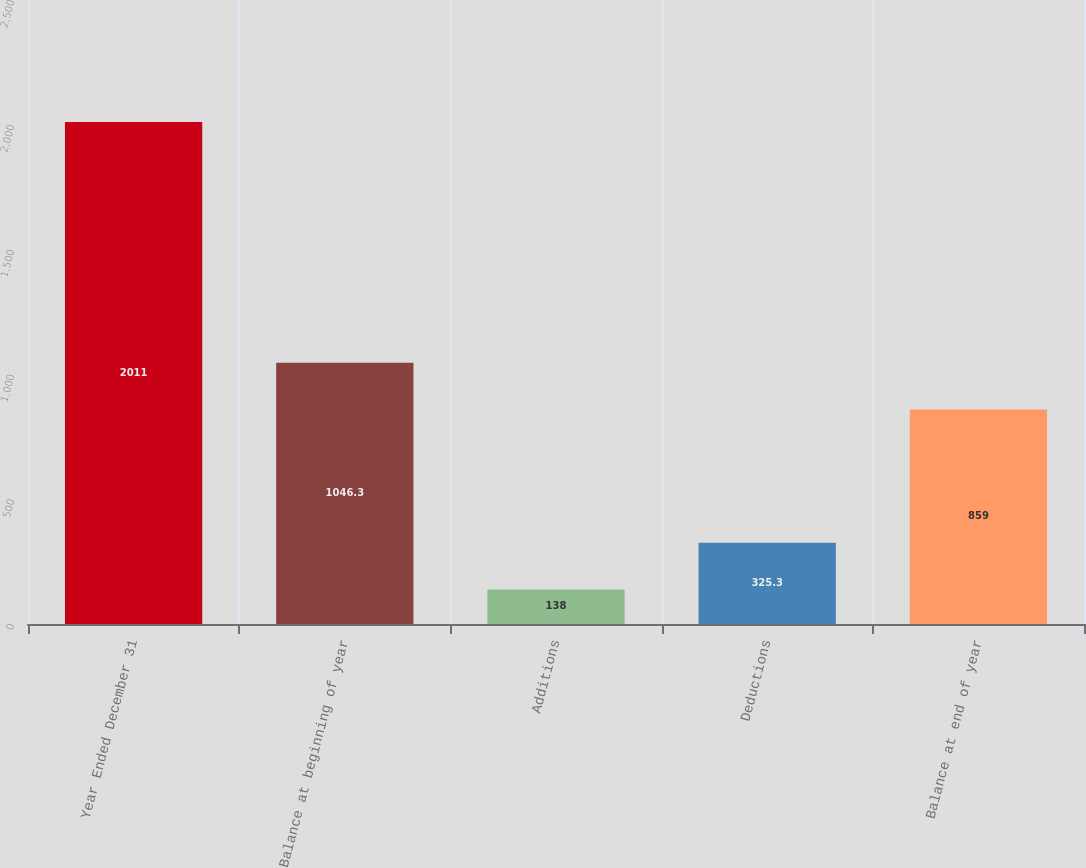<chart> <loc_0><loc_0><loc_500><loc_500><bar_chart><fcel>Year Ended December 31<fcel>Balance at beginning of year<fcel>Additions<fcel>Deductions<fcel>Balance at end of year<nl><fcel>2011<fcel>1046.3<fcel>138<fcel>325.3<fcel>859<nl></chart> 